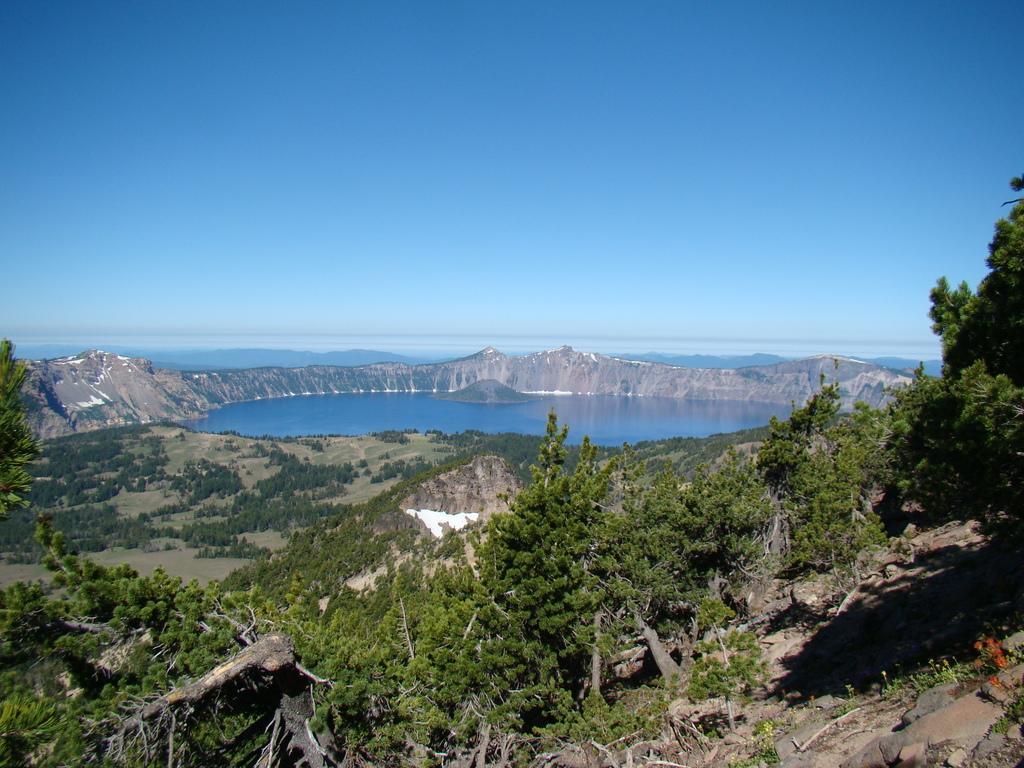Describe this image in one or two sentences. In this image we can see water, mountains, trees. At the top of the image there is sky. 